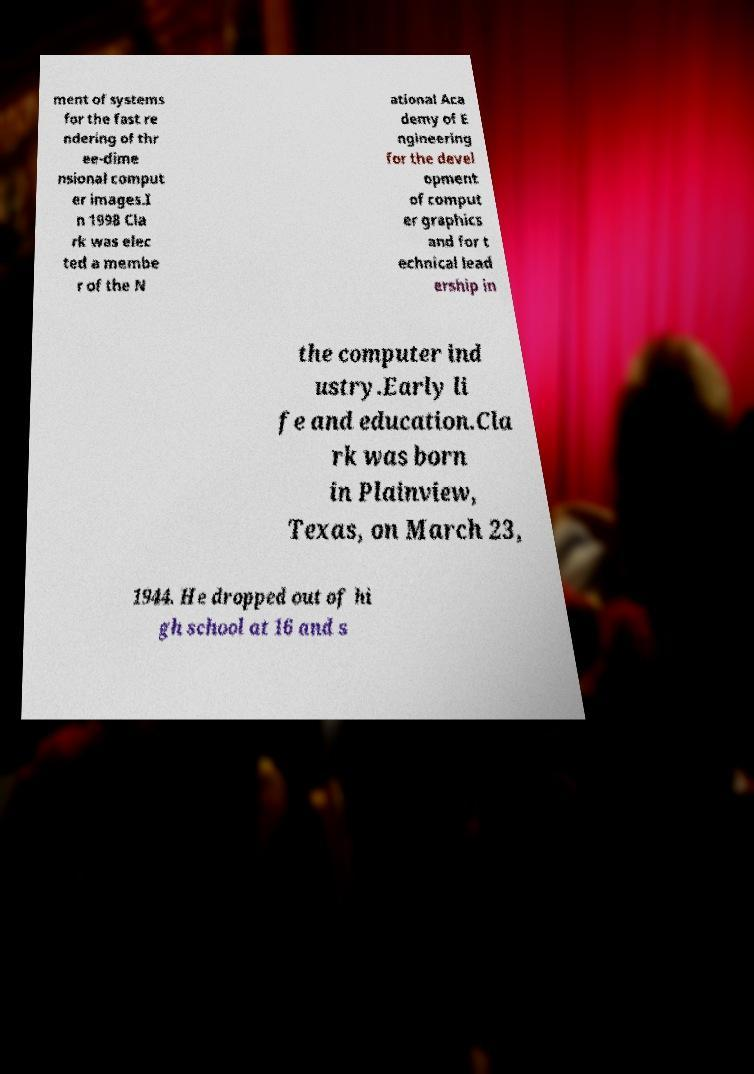Can you read and provide the text displayed in the image?This photo seems to have some interesting text. Can you extract and type it out for me? ment of systems for the fast re ndering of thr ee-dime nsional comput er images.I n 1998 Cla rk was elec ted a membe r of the N ational Aca demy of E ngineering for the devel opment of comput er graphics and for t echnical lead ership in the computer ind ustry.Early li fe and education.Cla rk was born in Plainview, Texas, on March 23, 1944. He dropped out of hi gh school at 16 and s 